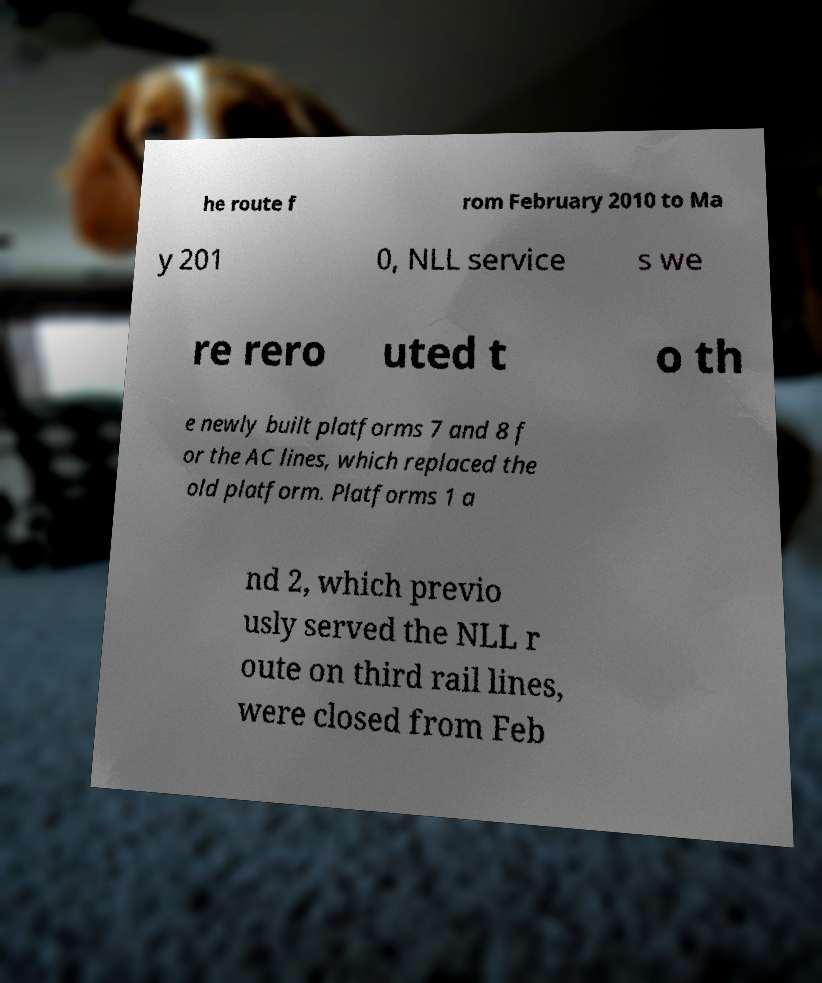Please read and relay the text visible in this image. What does it say? he route f rom February 2010 to Ma y 201 0, NLL service s we re rero uted t o th e newly built platforms 7 and 8 f or the AC lines, which replaced the old platform. Platforms 1 a nd 2, which previo usly served the NLL r oute on third rail lines, were closed from Feb 